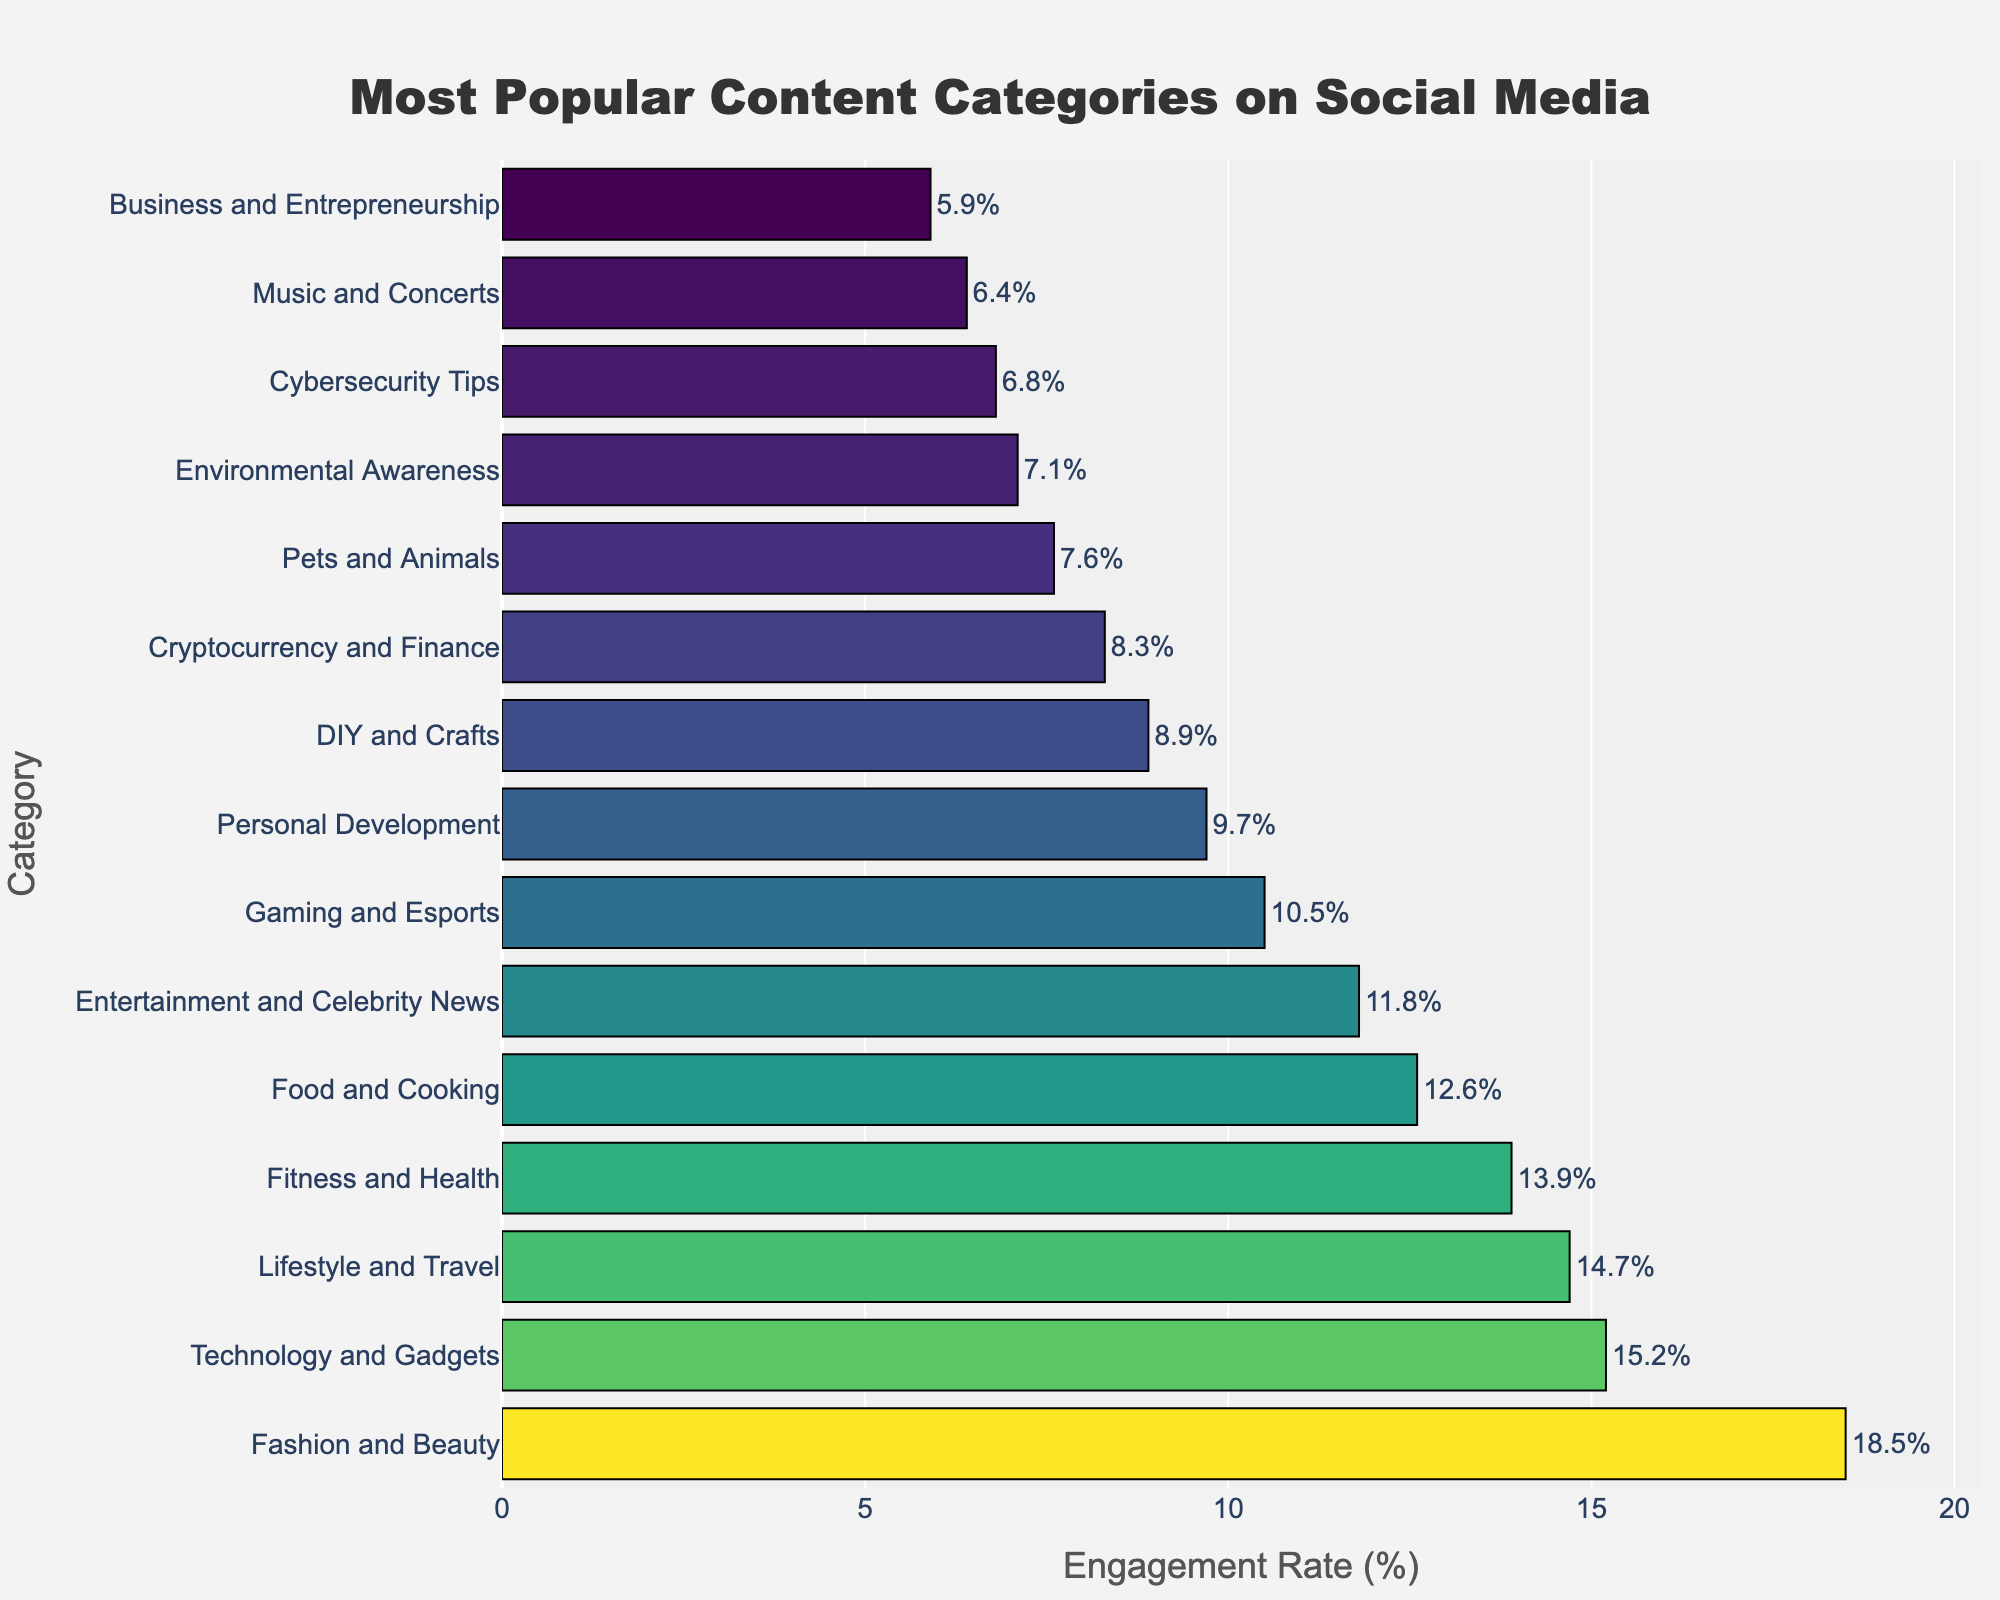Which category has the highest engagement rate? The category with the highest bar in the chart represents the highest engagement rate. "Fashion and Beauty" has the highest engagement rate at 18.5%.
Answer: Fashion and Beauty Which category has a higher engagement rate, Fitness and Health or Technology and Gadgets? Compare the heights of the bars for "Fitness and Health" and "Technology and Gadgets". "Technology and Gadgets" has a higher engagement rate at 15.2% compared to "Fitness and Health" at 13.9%.
Answer: Technology and Gadgets What is the total engagement rate for DIY and Crafts and Pets and Animals combined? Add the engagement rates for "DIY and Crafts" (8.9%) and "Pets and Animals" (7.6%). The combined engagement rate is 8.9% + 7.6% = 16.5%.
Answer: 16.5% Which content category has the smallest engagement rate? The category with the shortest bar in the chart will have the smallest engagement rate. "Business and Entrepreneurship" has the smallest engagement rate at 5.9%.
Answer: Business and Entrepreneurship Is the engagement rate for Gaming and Esports higher than for Music and Concerts? Compare the heights of the bars for "Gaming and Esports" and "Music and Concerts". "Gaming and Esports" has 10.5% and "Music and Concerts" has 6.4%, so Gaming and Esports is higher.
Answer: Yes How much higher is the engagement rate for Food and Cooking compared to Entertainment and Celebrity News? Subtract the engagement rate of "Entertainment and Celebrity News" (11.8%) from "Food and Cooking" (12.6%). The difference is 12.6% - 11.8% = 0.8%.
Answer: 0.8% Arrange these three categories in descending order of their engagement rate: Lifestyle and Travel, Cryptocurrency and Finance, Personal Development. Compare the engagement rates: Lifestyle and Travel (14.7%), Personal Development (9.7%), and Cryptocurrency and Finance (8.3%). The descending order is Lifestyle and Travel, Personal Development, Cryptocurrency and Finance.
Answer: Lifestyle and Travel, Personal Development, Cryptocurrency and Finance What is the average engagement rate for the top three categories? Add the engagement rates for the top three categories: "Fashion and Beauty" (18.5%), "Technology and Gadgets" (15.2%), and "Lifestyle and Travel" (14.7%), then divide by 3. (18.5% + 15.2% + 14.7%) / 3 ≈ 16.13%.
Answer: 16.13% Which category has the closest engagement rate to the median value of all categories' engagement rates? List the engagement rates in order: 5.9%, 6.4%, 6.8%, 7.1%, 7.6%, 8.3%, 8.9%, 9.7%, 10.5%, 11.8%, 12.6%, 13.9%, 14.7%, 15.2%, 18.5%. The median value is the middle one (8.9%), which corresponds to "DIY and Crafts".
Answer: DIY and Crafts 